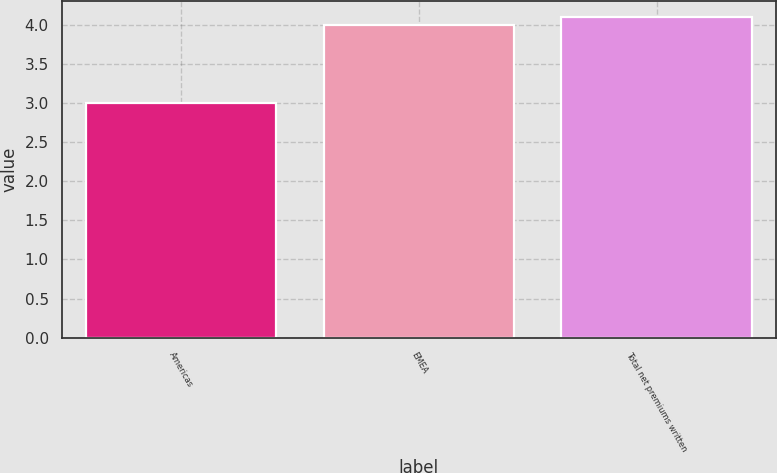Convert chart. <chart><loc_0><loc_0><loc_500><loc_500><bar_chart><fcel>Americas<fcel>EMEA<fcel>Total net premiums written<nl><fcel>3<fcel>4<fcel>4.1<nl></chart> 